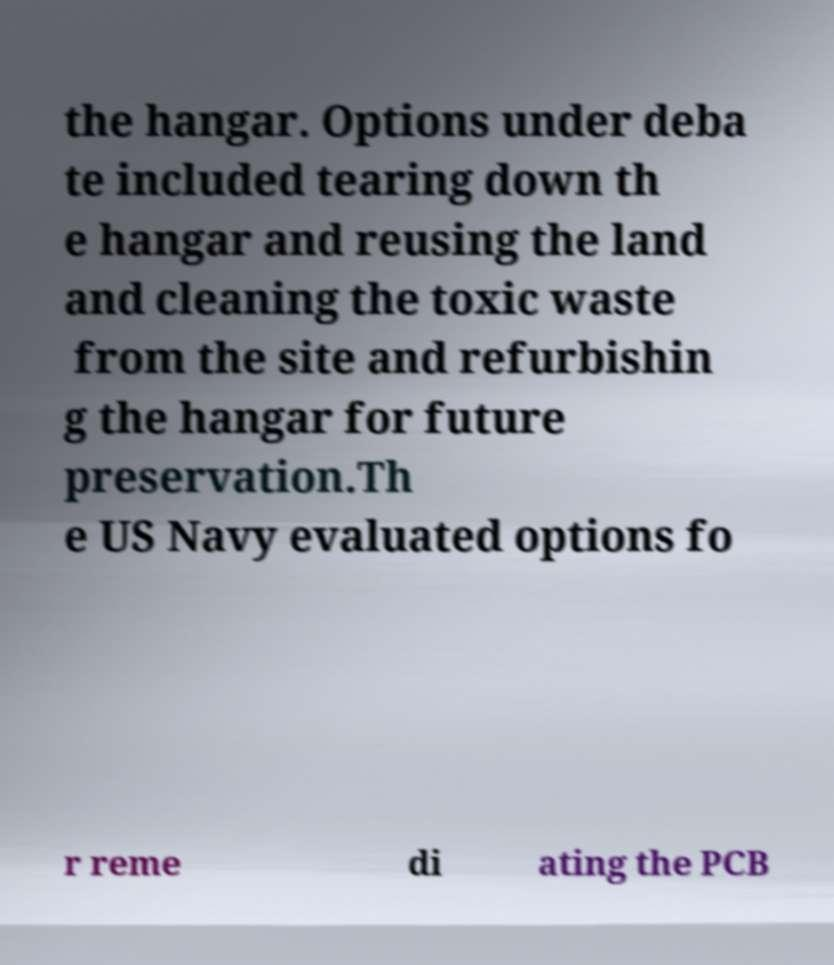Please read and relay the text visible in this image. What does it say? the hangar. Options under deba te included tearing down th e hangar and reusing the land and cleaning the toxic waste from the site and refurbishin g the hangar for future preservation.Th e US Navy evaluated options fo r reme di ating the PCB 